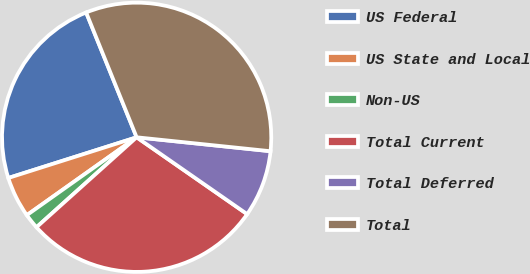<chart> <loc_0><loc_0><loc_500><loc_500><pie_chart><fcel>US Federal<fcel>US State and Local<fcel>Non-US<fcel>Total Current<fcel>Total Deferred<fcel>Total<nl><fcel>23.77%<fcel>4.93%<fcel>1.83%<fcel>28.68%<fcel>8.02%<fcel>32.77%<nl></chart> 